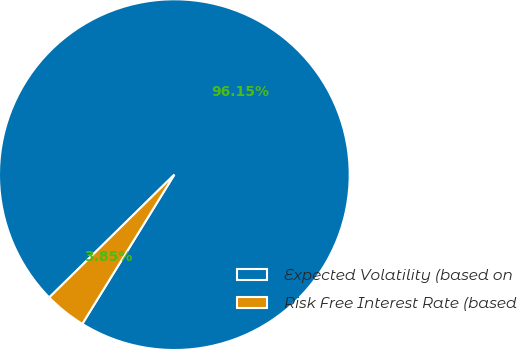<chart> <loc_0><loc_0><loc_500><loc_500><pie_chart><fcel>Expected Volatility (based on<fcel>Risk Free Interest Rate (based<nl><fcel>96.15%<fcel>3.85%<nl></chart> 